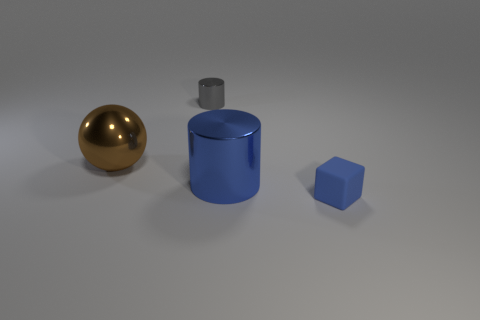What size is the thing that is the same color as the tiny cube?
Provide a succinct answer. Large. How many rubber objects are large cylinders or blue blocks?
Make the answer very short. 1. There is a big shiny object that is on the right side of the metal cylinder behind the metal ball; is there a thing in front of it?
Your response must be concise. Yes. How many big blue metallic things are on the right side of the brown thing?
Make the answer very short. 1. What is the material of the small object that is the same color as the big metal cylinder?
Your answer should be very brief. Rubber. What number of tiny things are either cyan metallic things or shiny objects?
Ensure brevity in your answer.  1. There is a large metal thing that is right of the brown metallic ball; what is its shape?
Keep it short and to the point. Cylinder. Is there a large cylinder that has the same color as the cube?
Your answer should be very brief. Yes. There is a shiny object that is left of the gray shiny cylinder; is it the same size as the thing in front of the large cylinder?
Ensure brevity in your answer.  No. Is the number of large things on the right side of the brown shiny ball greater than the number of tiny objects that are behind the small metal cylinder?
Give a very brief answer. Yes. 